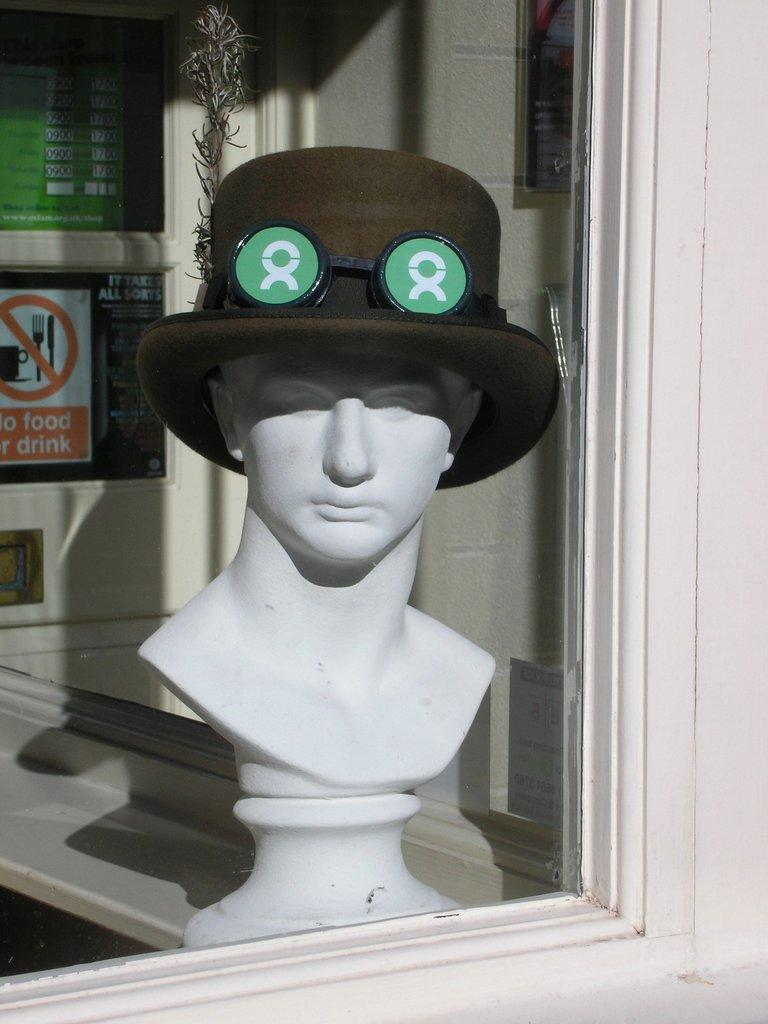What object is present in the image that can hold liquid? There is a glass in the image. What is inside the glass in the image? A mannequin with a hat is visible inside the glass. What can be seen in the background of the image? There are many boards and a wall visible in the background of the image. What is the rate of the battle happening in the image? There is no battle present in the image, so it is not possible to determine a rate. 